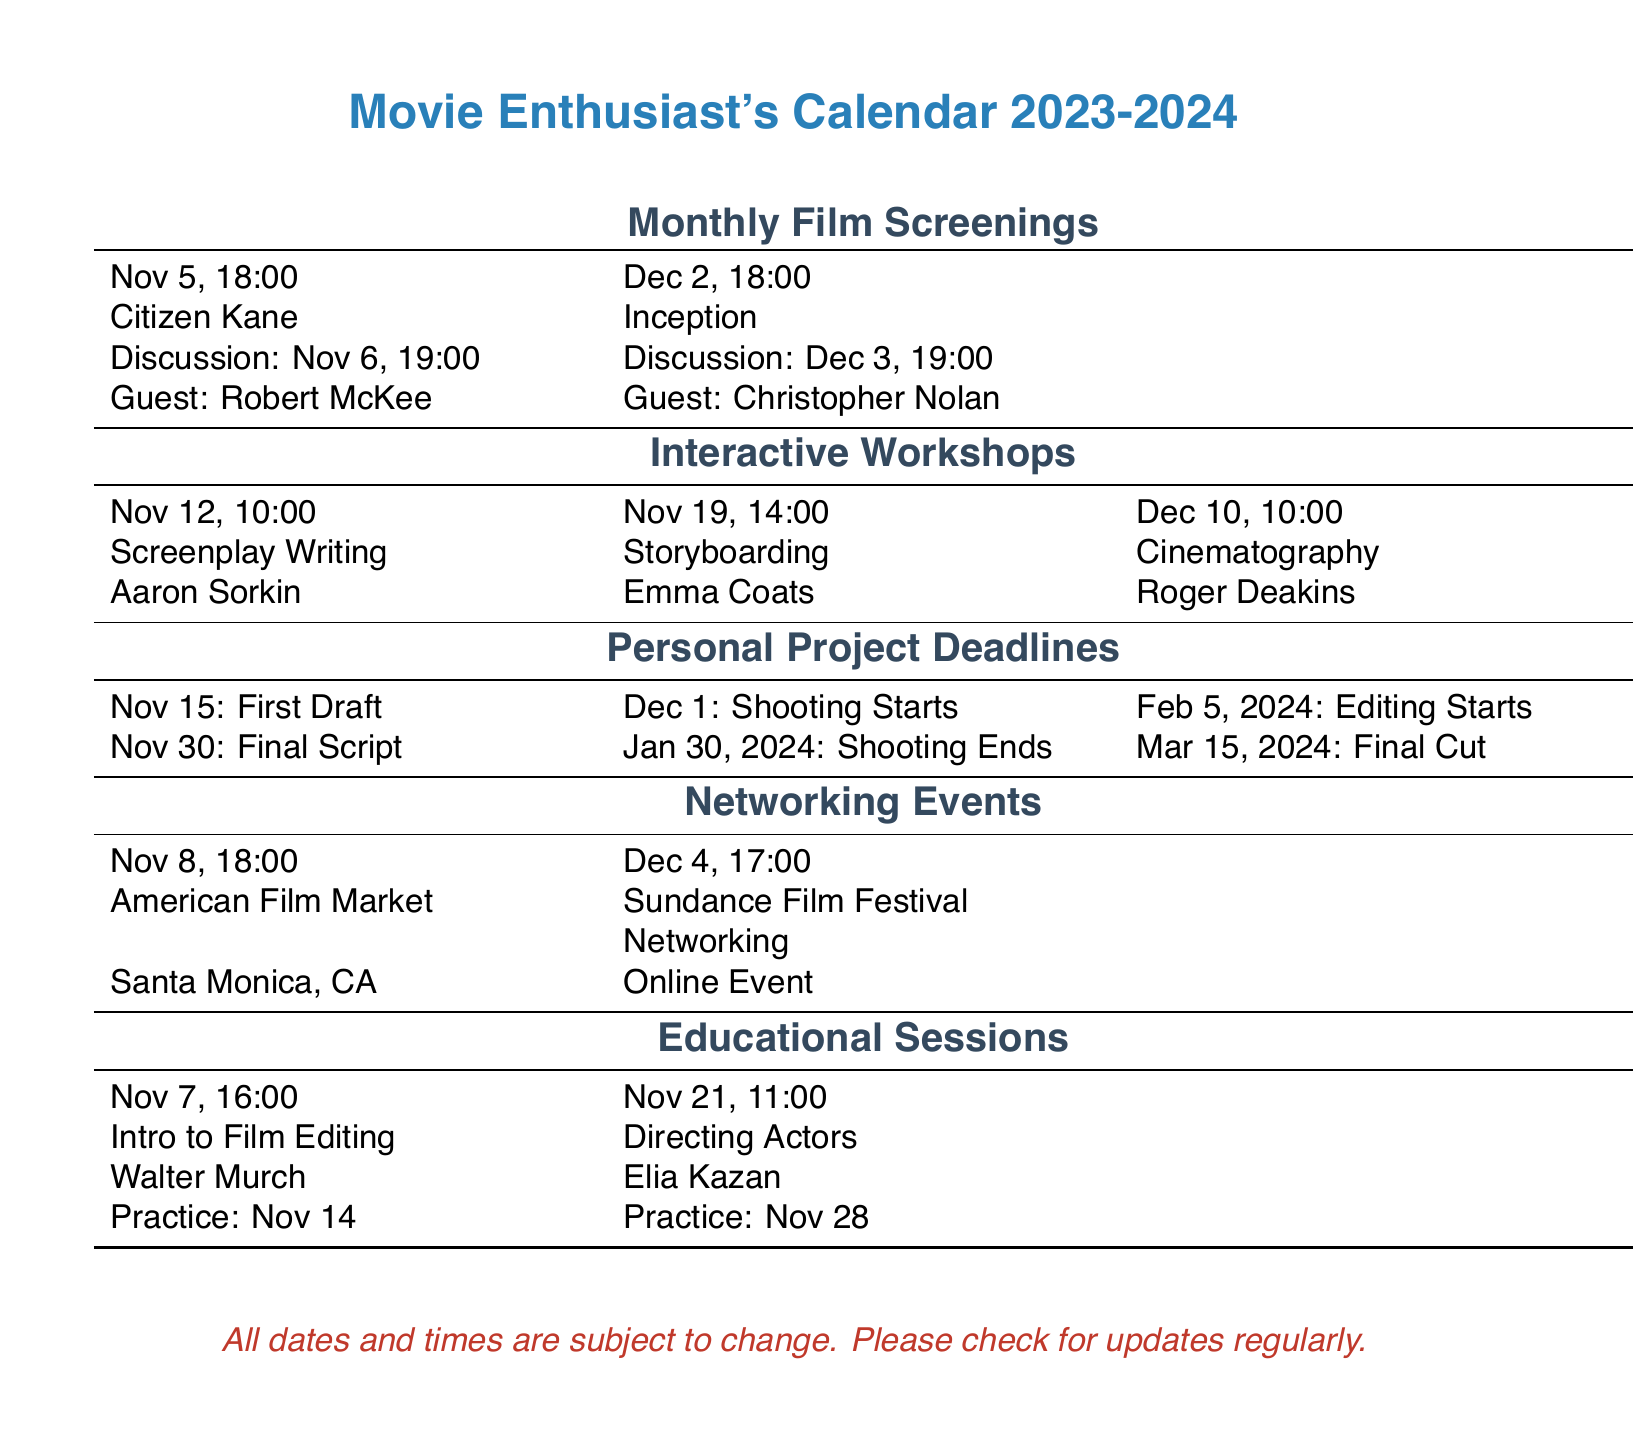What film is screened on November 5? The film listed for screening on November 5 is "Citizen Kane."
Answer: Citizen Kane Who is the guest speaker for the December 2 screening? The document states that Christopher Nolan will be the guest speaker for the December 2 screening.
Answer: Christopher Nolan What is the date for the first draft submission? The first draft submission is due on November 15 according to the personal project deadlines.
Answer: November 15 Which day is the workshop on Storyboarding scheduled? The Storyboarding workshop is scheduled for November 19.
Answer: November 19 How many workshops are listed in the document? The document lists a total of three interactive workshops for November and December.
Answer: Three What is the title of the educational session on November 21? The educational session on November 21 is titled "Directing Actors."
Answer: Directing Actors When does shooting for personal projects start? According to the personal project deadlines, shooting starts on December 1.
Answer: December 1 What is the location of the American Film Market event? The American Film Market event is located in Santa Monica, CA.
Answer: Santa Monica, CA How many educational sessions are scheduled before November 28? There are two educational sessions scheduled before November 28, as the practice for one session is on that date.
Answer: Two 